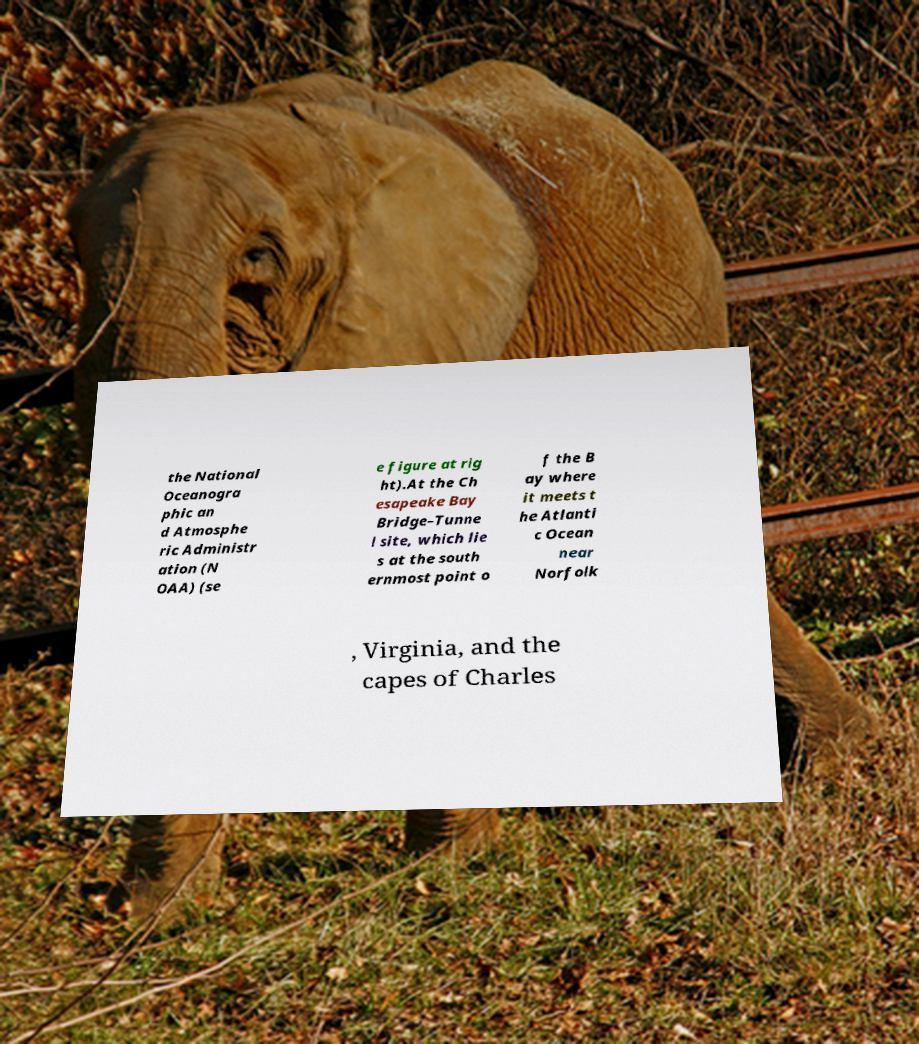For documentation purposes, I need the text within this image transcribed. Could you provide that? the National Oceanogra phic an d Atmosphe ric Administr ation (N OAA) (se e figure at rig ht).At the Ch esapeake Bay Bridge–Tunne l site, which lie s at the south ernmost point o f the B ay where it meets t he Atlanti c Ocean near Norfolk , Virginia, and the capes of Charles 